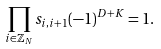<formula> <loc_0><loc_0><loc_500><loc_500>\prod _ { i \in \mathbb { Z } _ { N } } s _ { i , i + 1 } ( - 1 ) ^ { D + K } = 1 .</formula> 